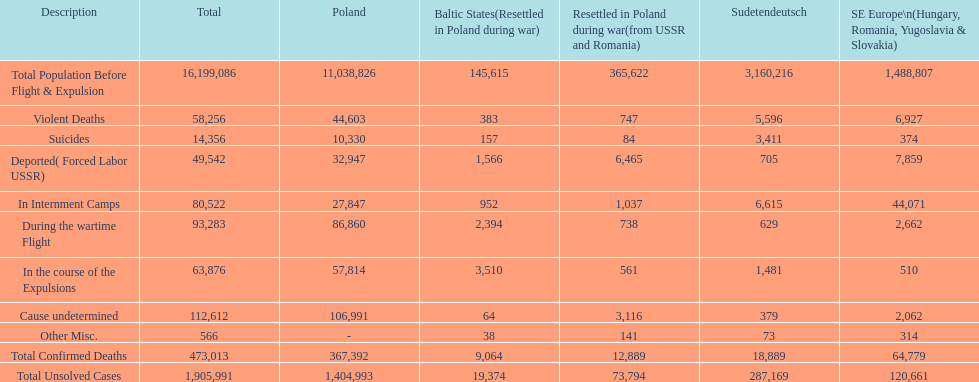What is the total of deaths in internment camps and during the wartime flight? 173,805. 